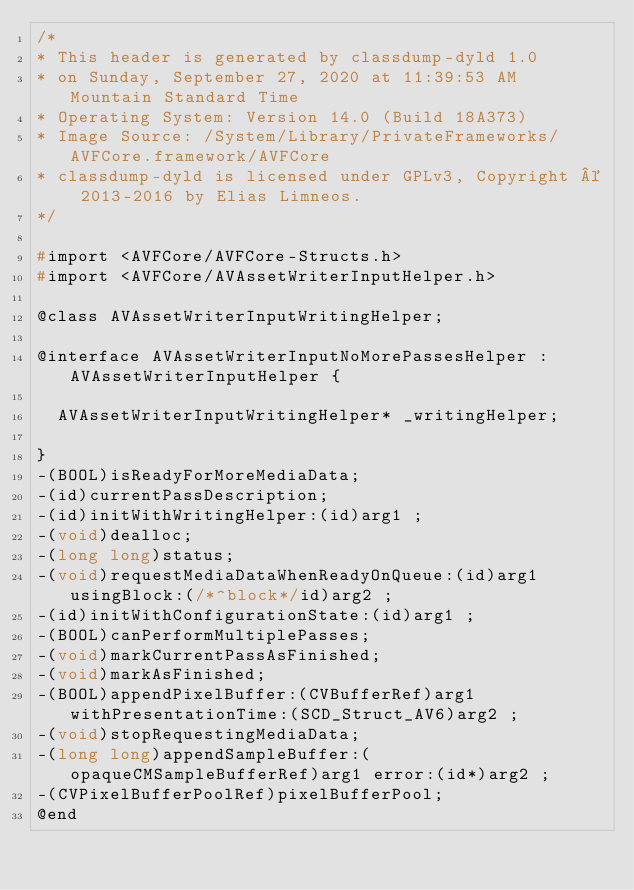<code> <loc_0><loc_0><loc_500><loc_500><_C_>/*
* This header is generated by classdump-dyld 1.0
* on Sunday, September 27, 2020 at 11:39:53 AM Mountain Standard Time
* Operating System: Version 14.0 (Build 18A373)
* Image Source: /System/Library/PrivateFrameworks/AVFCore.framework/AVFCore
* classdump-dyld is licensed under GPLv3, Copyright © 2013-2016 by Elias Limneos.
*/

#import <AVFCore/AVFCore-Structs.h>
#import <AVFCore/AVAssetWriterInputHelper.h>

@class AVAssetWriterInputWritingHelper;

@interface AVAssetWriterInputNoMorePassesHelper : AVAssetWriterInputHelper {

	AVAssetWriterInputWritingHelper* _writingHelper;

}
-(BOOL)isReadyForMoreMediaData;
-(id)currentPassDescription;
-(id)initWithWritingHelper:(id)arg1 ;
-(void)dealloc;
-(long long)status;
-(void)requestMediaDataWhenReadyOnQueue:(id)arg1 usingBlock:(/*^block*/id)arg2 ;
-(id)initWithConfigurationState:(id)arg1 ;
-(BOOL)canPerformMultiplePasses;
-(void)markCurrentPassAsFinished;
-(void)markAsFinished;
-(BOOL)appendPixelBuffer:(CVBufferRef)arg1 withPresentationTime:(SCD_Struct_AV6)arg2 ;
-(void)stopRequestingMediaData;
-(long long)appendSampleBuffer:(opaqueCMSampleBufferRef)arg1 error:(id*)arg2 ;
-(CVPixelBufferPoolRef)pixelBufferPool;
@end

</code> 